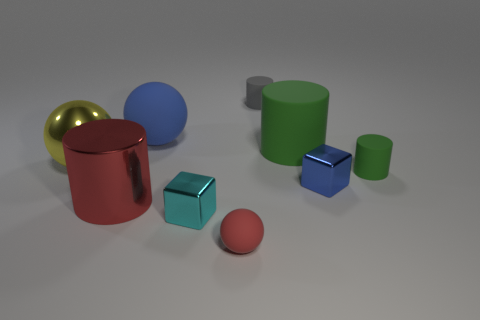Subtract all cylinders. How many objects are left? 5 Subtract all big cylinders. Subtract all cyan metallic blocks. How many objects are left? 6 Add 7 cyan things. How many cyan things are left? 8 Add 5 blue matte spheres. How many blue matte spheres exist? 6 Subtract 0 cyan spheres. How many objects are left? 9 